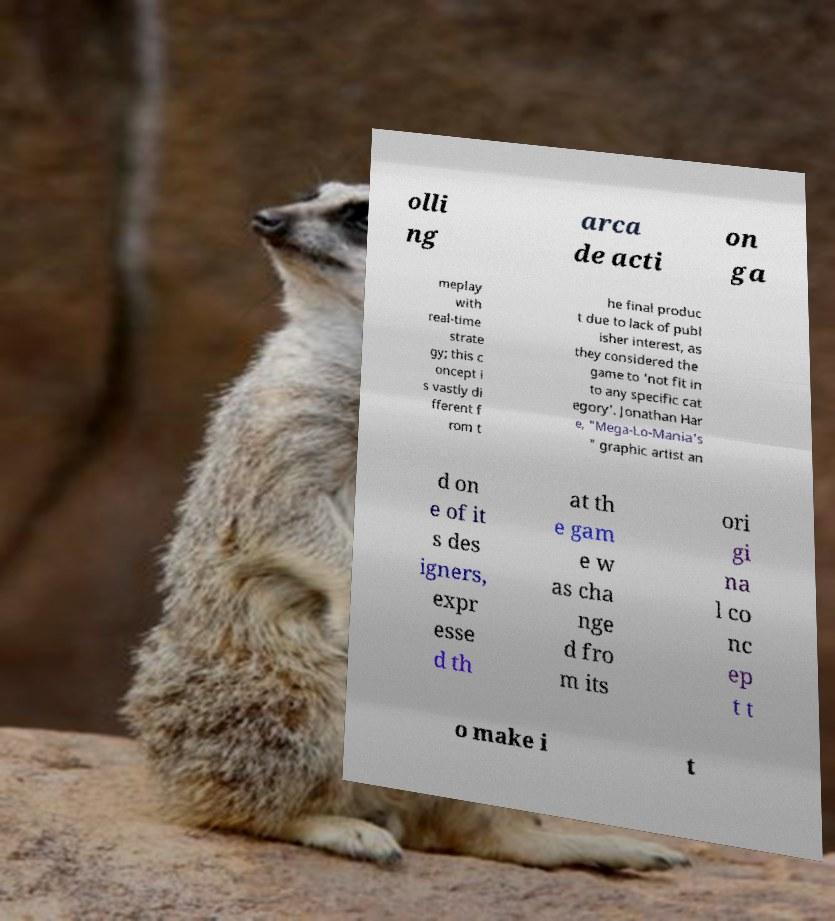What messages or text are displayed in this image? I need them in a readable, typed format. olli ng arca de acti on ga meplay with real-time strate gy; this c oncept i s vastly di fferent f rom t he final produc t due to lack of publ isher interest, as they considered the game to 'not fit in to any specific cat egory'. Jonathan Har e, "Mega-Lo-Mania's " graphic artist an d on e of it s des igners, expr esse d th at th e gam e w as cha nge d fro m its ori gi na l co nc ep t t o make i t 